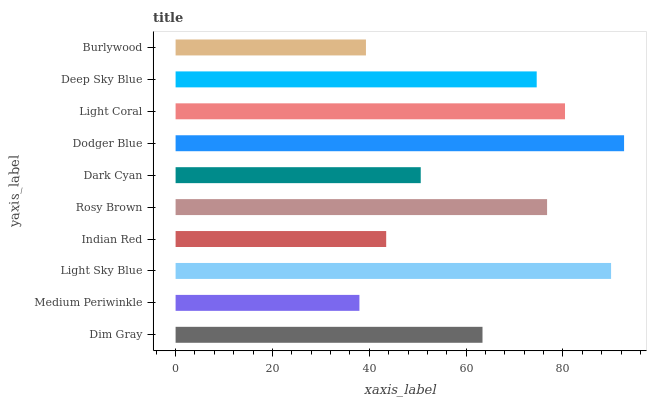Is Medium Periwinkle the minimum?
Answer yes or no. Yes. Is Dodger Blue the maximum?
Answer yes or no. Yes. Is Light Sky Blue the minimum?
Answer yes or no. No. Is Light Sky Blue the maximum?
Answer yes or no. No. Is Light Sky Blue greater than Medium Periwinkle?
Answer yes or no. Yes. Is Medium Periwinkle less than Light Sky Blue?
Answer yes or no. Yes. Is Medium Periwinkle greater than Light Sky Blue?
Answer yes or no. No. Is Light Sky Blue less than Medium Periwinkle?
Answer yes or no. No. Is Deep Sky Blue the high median?
Answer yes or no. Yes. Is Dim Gray the low median?
Answer yes or no. Yes. Is Dark Cyan the high median?
Answer yes or no. No. Is Dark Cyan the low median?
Answer yes or no. No. 